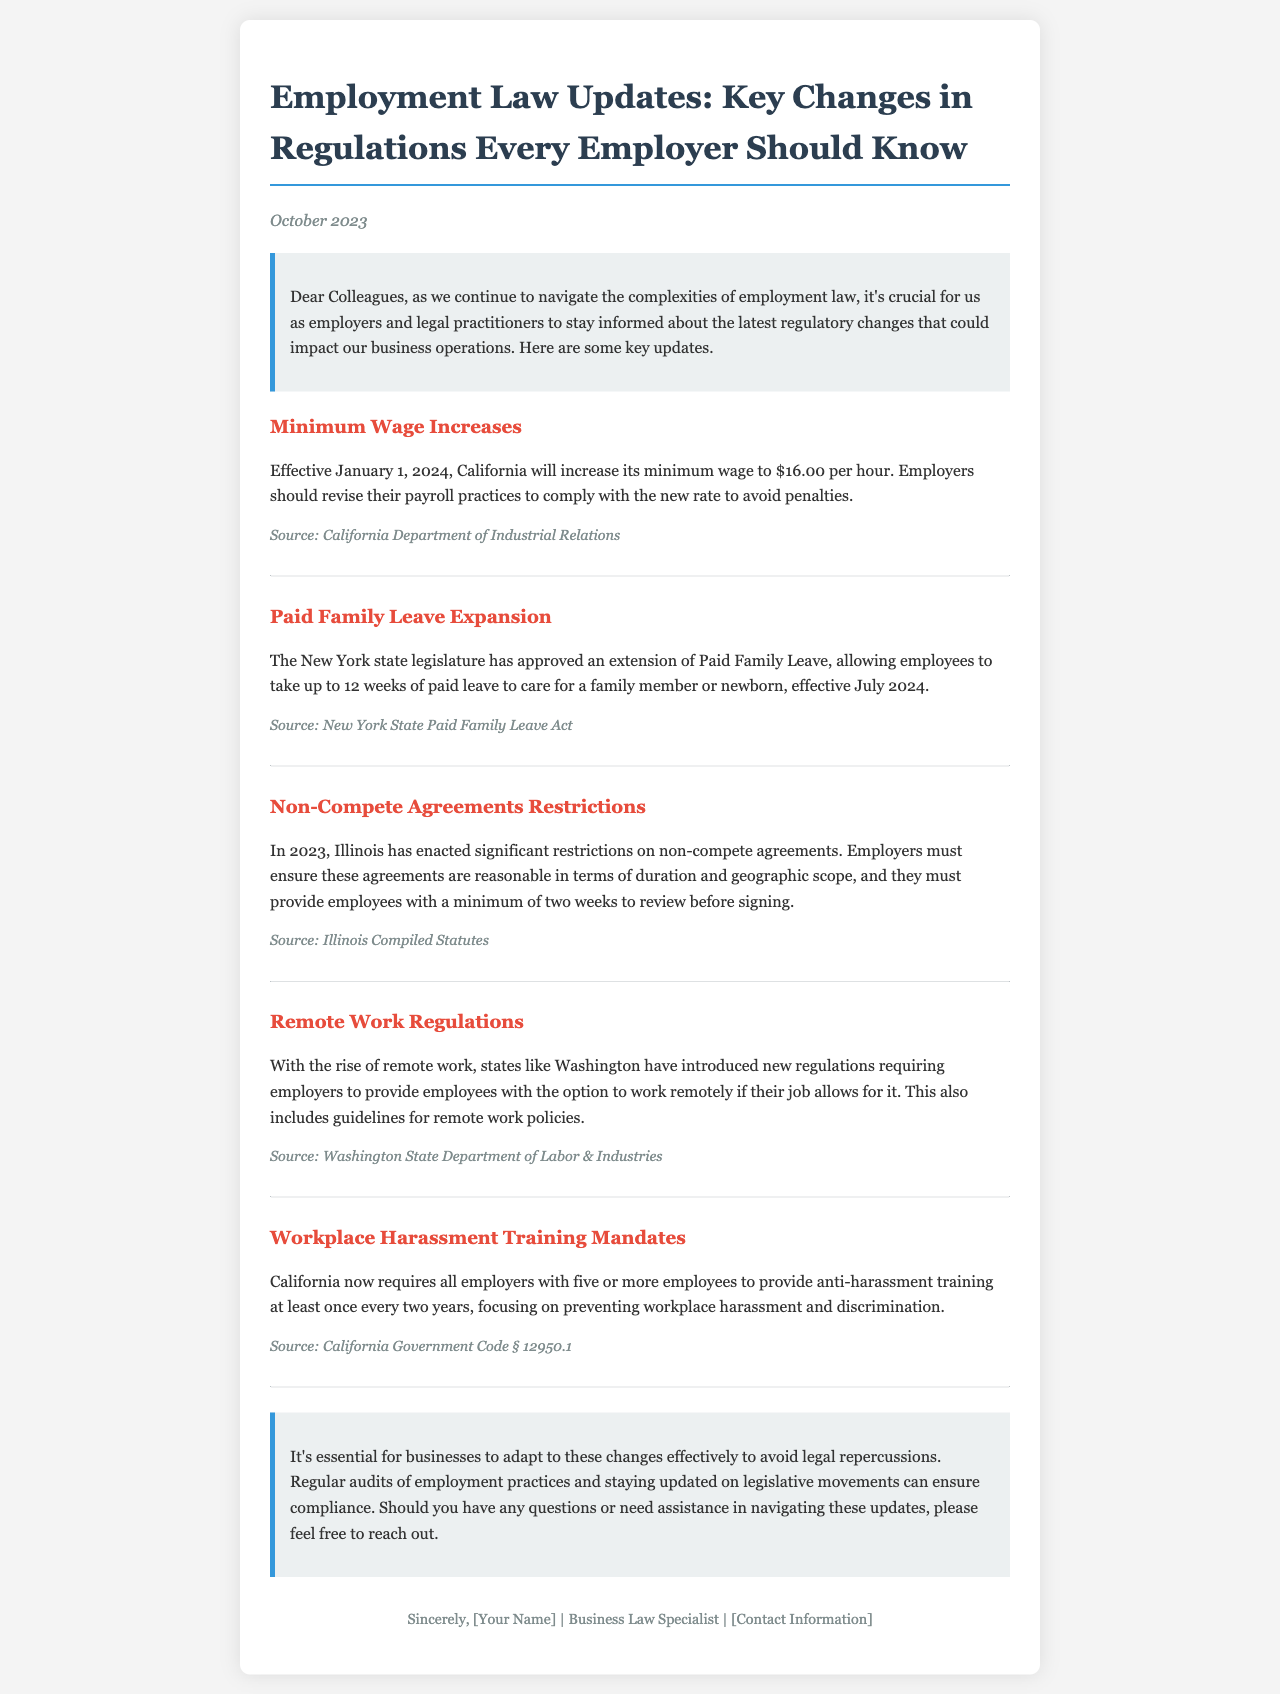What is the new minimum wage in California? The new minimum wage is mentioned as effective from January 1, 2024, set at $16.00 per hour.
Answer: $16.00 per hour When will the Paid Family Leave expansion take effect in New York? The newsletter states that the expansion of Paid Family Leave will be effective from July 2024.
Answer: July 2024 How long can employees take Paid Family Leave in New York? The update indicates that employees can take up to 12 weeks of paid leave.
Answer: 12 weeks What is the requirement for non-compete agreements in Illinois? Employers must ensure agreements are reasonable and provide employees a minimum of two weeks to review before signing.
Answer: Two weeks What is the focus of the anti-harassment training mandated in California? The training focuses on preventing workplace harassment and discrimination.
Answer: Preventing workplace harassment and discrimination Which state introduced new regulations for remote work? The newsletter specifies that Washington has introduced new regulations regarding remote work.
Answer: Washington How often must California employers provide anti-harassment training? The document states that employers are required to provide training at least once every two years.
Answer: Once every two years What is the purpose of the newsletter? The primary purpose of the newsletter is to inform employers and legal practitioners about recent regulatory changes in employment law.
Answer: Inform employers and legal practitioners What major change was mentioned regarding minimum wages? The newsletter highlights an increase in minimum wage in California, effective January 1, 2024.
Answer: Increase in minimum wage 